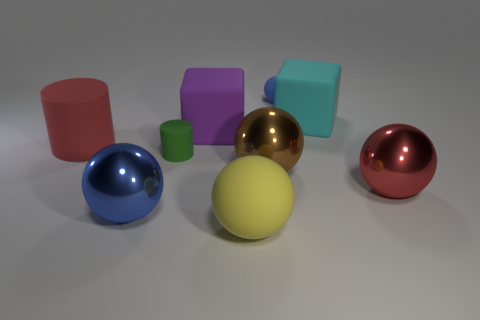What number of small blue blocks are there?
Offer a very short reply. 0. Is the shape of the green object the same as the red object that is on the left side of the large cyan rubber object?
Keep it short and to the point. Yes. How many things are either large blue shiny objects or big shiny objects to the left of the large cyan block?
Give a very brief answer. 2. There is a red object that is the same shape as the tiny blue matte thing; what is it made of?
Provide a succinct answer. Metal. There is a blue object to the left of the green cylinder; is it the same shape as the purple rubber object?
Your response must be concise. No. Are there fewer small rubber balls that are in front of the purple thing than yellow rubber spheres behind the tiny rubber ball?
Your answer should be very brief. No. How many other things are there of the same shape as the big yellow object?
Keep it short and to the point. 4. What is the size of the matte cylinder that is on the left side of the blue ball to the left of the blue thing behind the large red cylinder?
Your response must be concise. Large. What number of green things are small spheres or tiny matte things?
Give a very brief answer. 1. What is the shape of the big red thing that is to the right of the blue thing on the right side of the big purple block?
Your response must be concise. Sphere. 